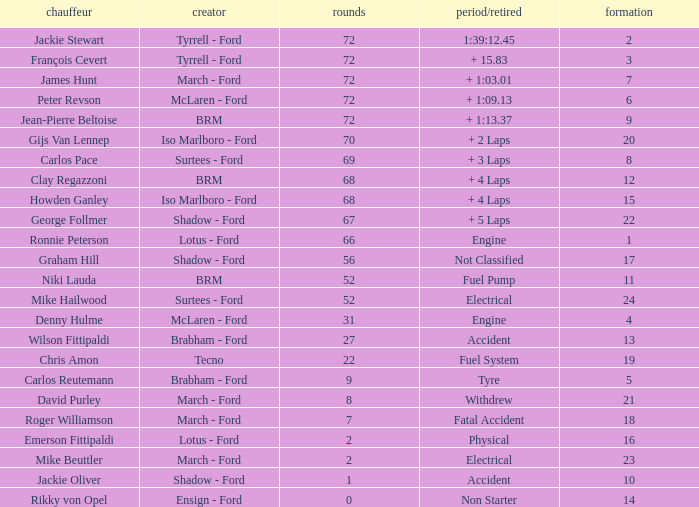What is the top grid that roger williamson lapped less than 7? None. 